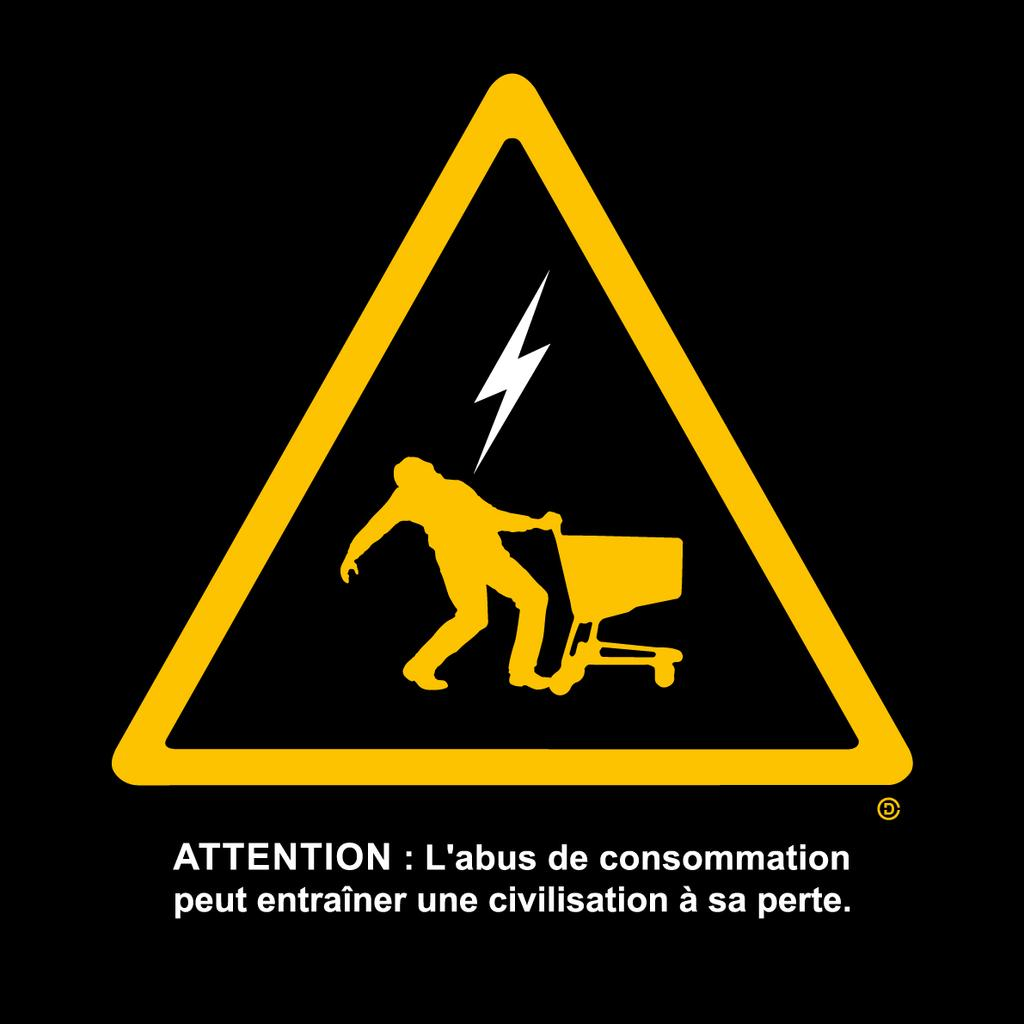<image>
Provide a brief description of the given image. A sign showing a person being shocked that says Attention. 